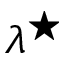Convert formula to latex. <formula><loc_0><loc_0><loc_500><loc_500>\lambda ^ { ^ { * } }</formula> 